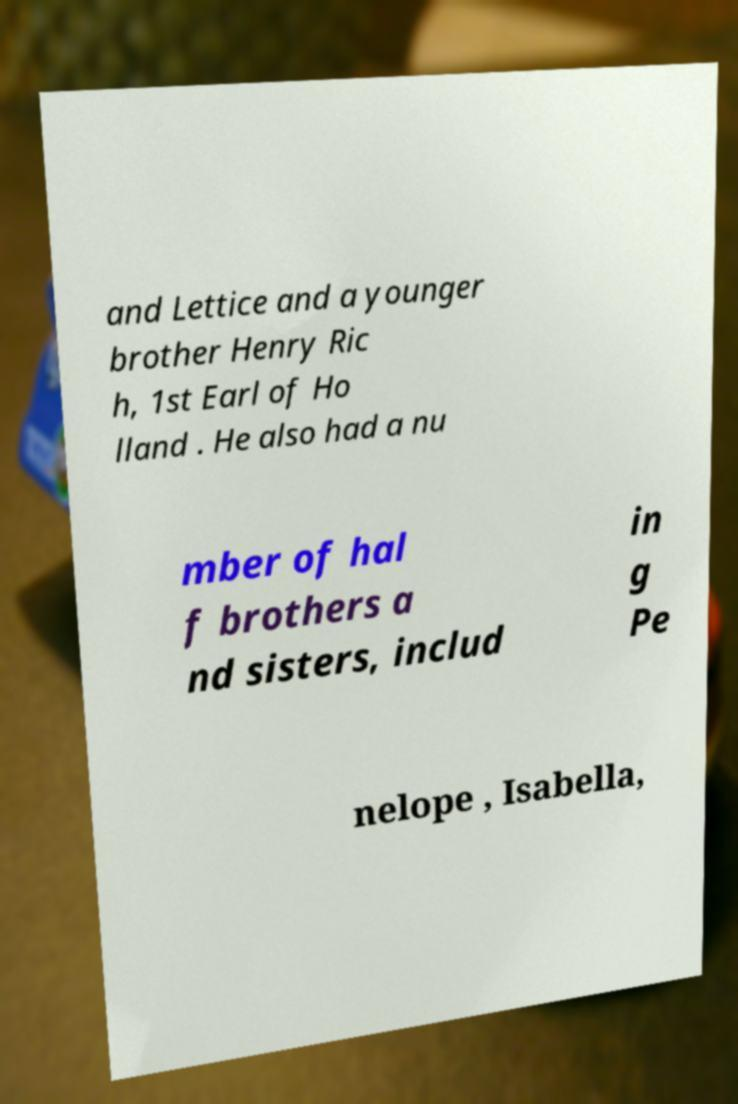Can you accurately transcribe the text from the provided image for me? and Lettice and a younger brother Henry Ric h, 1st Earl of Ho lland . He also had a nu mber of hal f brothers a nd sisters, includ in g Pe nelope , Isabella, 